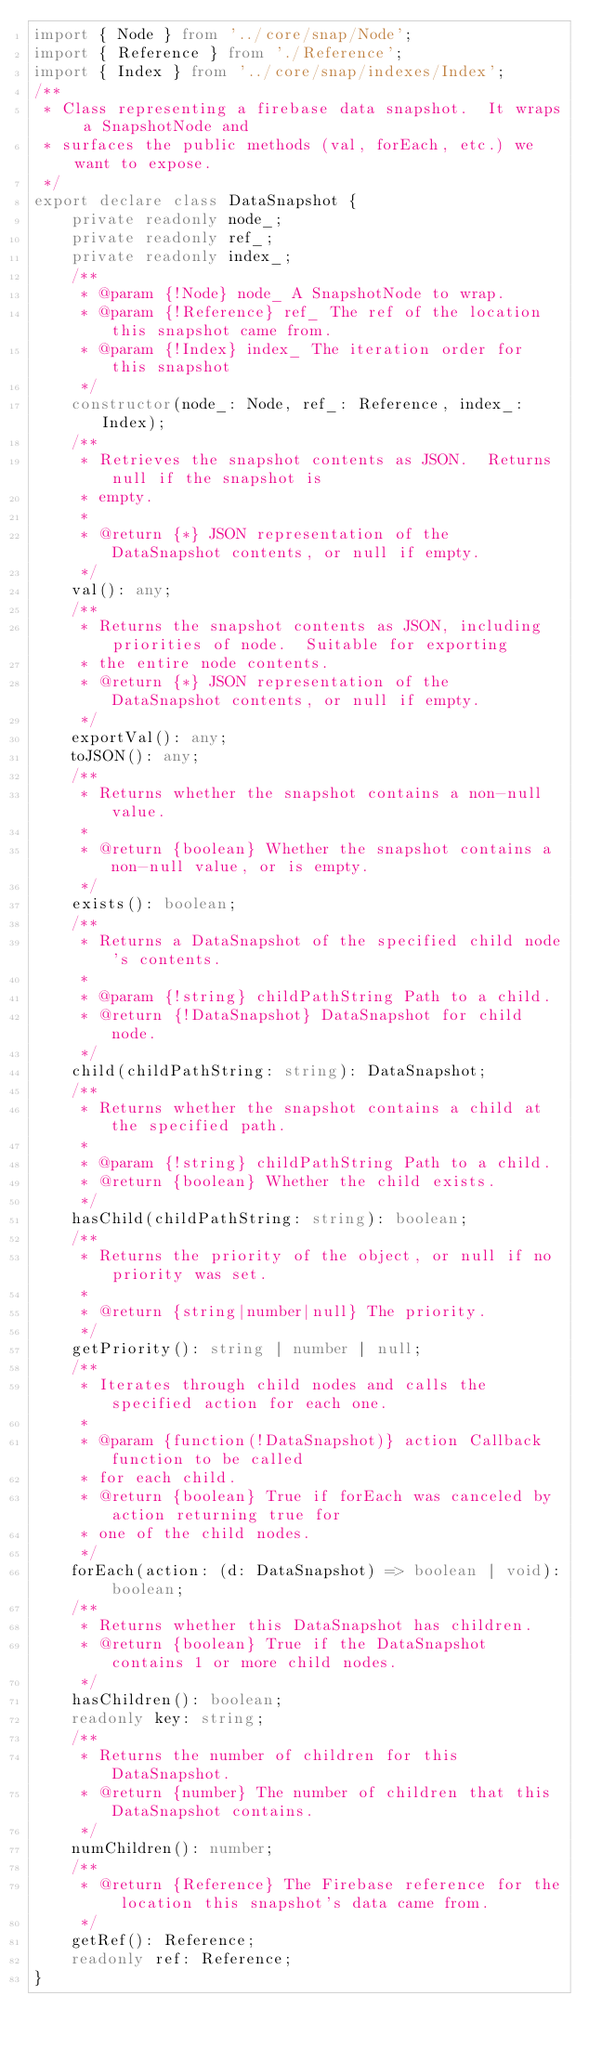Convert code to text. <code><loc_0><loc_0><loc_500><loc_500><_TypeScript_>import { Node } from '../core/snap/Node';
import { Reference } from './Reference';
import { Index } from '../core/snap/indexes/Index';
/**
 * Class representing a firebase data snapshot.  It wraps a SnapshotNode and
 * surfaces the public methods (val, forEach, etc.) we want to expose.
 */
export declare class DataSnapshot {
    private readonly node_;
    private readonly ref_;
    private readonly index_;
    /**
     * @param {!Node} node_ A SnapshotNode to wrap.
     * @param {!Reference} ref_ The ref of the location this snapshot came from.
     * @param {!Index} index_ The iteration order for this snapshot
     */
    constructor(node_: Node, ref_: Reference, index_: Index);
    /**
     * Retrieves the snapshot contents as JSON.  Returns null if the snapshot is
     * empty.
     *
     * @return {*} JSON representation of the DataSnapshot contents, or null if empty.
     */
    val(): any;
    /**
     * Returns the snapshot contents as JSON, including priorities of node.  Suitable for exporting
     * the entire node contents.
     * @return {*} JSON representation of the DataSnapshot contents, or null if empty.
     */
    exportVal(): any;
    toJSON(): any;
    /**
     * Returns whether the snapshot contains a non-null value.
     *
     * @return {boolean} Whether the snapshot contains a non-null value, or is empty.
     */
    exists(): boolean;
    /**
     * Returns a DataSnapshot of the specified child node's contents.
     *
     * @param {!string} childPathString Path to a child.
     * @return {!DataSnapshot} DataSnapshot for child node.
     */
    child(childPathString: string): DataSnapshot;
    /**
     * Returns whether the snapshot contains a child at the specified path.
     *
     * @param {!string} childPathString Path to a child.
     * @return {boolean} Whether the child exists.
     */
    hasChild(childPathString: string): boolean;
    /**
     * Returns the priority of the object, or null if no priority was set.
     *
     * @return {string|number|null} The priority.
     */
    getPriority(): string | number | null;
    /**
     * Iterates through child nodes and calls the specified action for each one.
     *
     * @param {function(!DataSnapshot)} action Callback function to be called
     * for each child.
     * @return {boolean} True if forEach was canceled by action returning true for
     * one of the child nodes.
     */
    forEach(action: (d: DataSnapshot) => boolean | void): boolean;
    /**
     * Returns whether this DataSnapshot has children.
     * @return {boolean} True if the DataSnapshot contains 1 or more child nodes.
     */
    hasChildren(): boolean;
    readonly key: string;
    /**
     * Returns the number of children for this DataSnapshot.
     * @return {number} The number of children that this DataSnapshot contains.
     */
    numChildren(): number;
    /**
     * @return {Reference} The Firebase reference for the location this snapshot's data came from.
     */
    getRef(): Reference;
    readonly ref: Reference;
}
</code> 